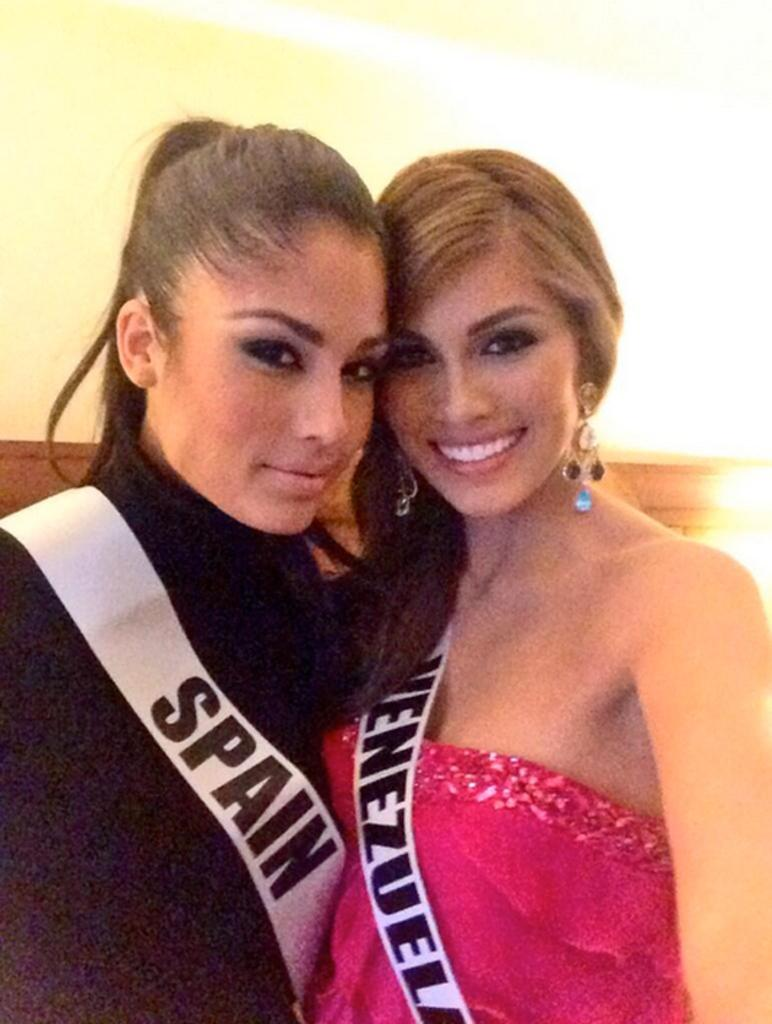Provide a one-sentence caption for the provided image. The two beauty pageant contestants are from Spain and Venezuela. 